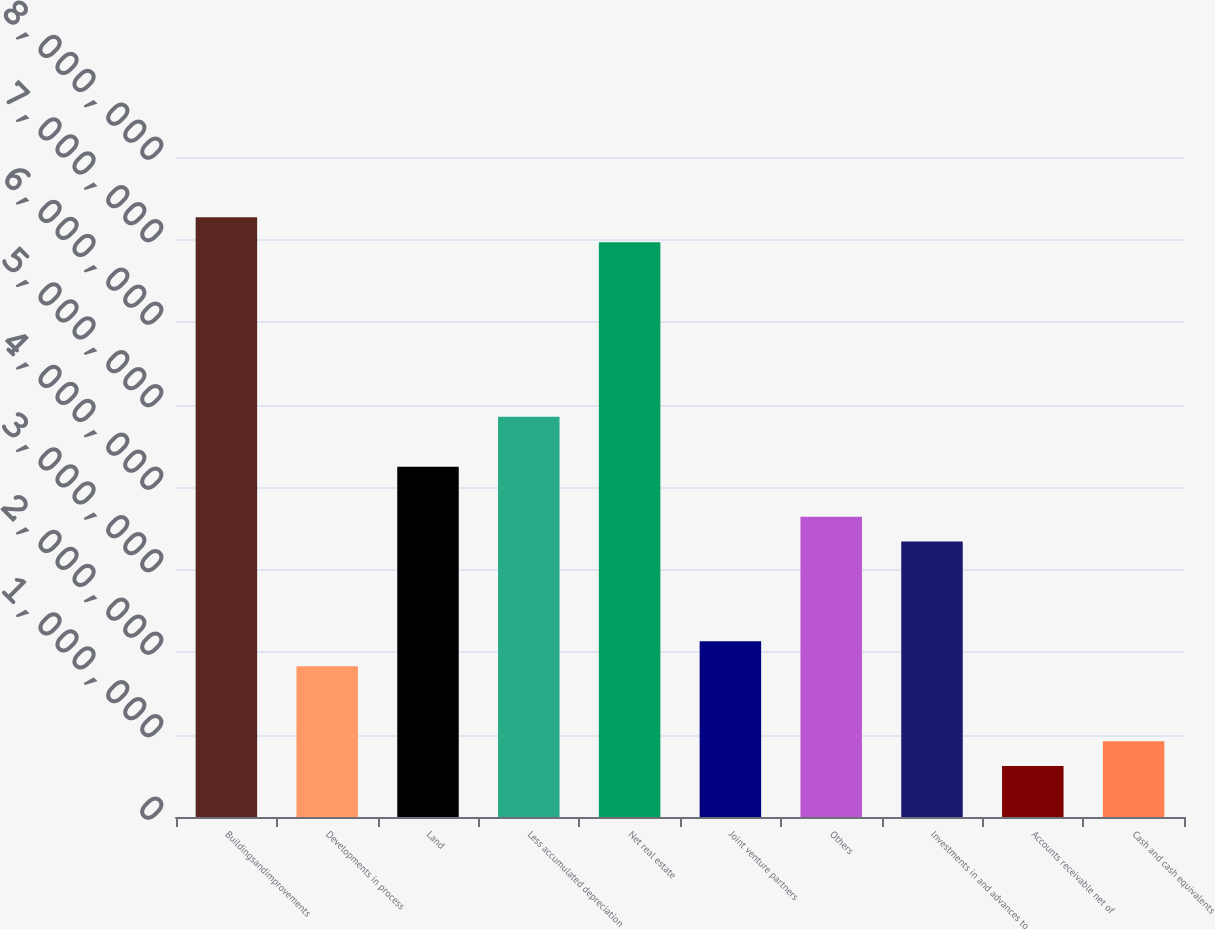Convert chart. <chart><loc_0><loc_0><loc_500><loc_500><bar_chart><fcel>Buildingsandimprovements<fcel>Developments in process<fcel>Land<fcel>Less accumulated depreciation<fcel>Net real estate<fcel>Joint venture partners<fcel>Others<fcel>Investments in and advances to<fcel>Accounts receivable net of<fcel>Cash and cash equivalents<nl><fcel>7.26919e+06<fcel>1.82646e+06<fcel>4.24545e+06<fcel>4.8502e+06<fcel>6.96682e+06<fcel>2.12884e+06<fcel>3.6407e+06<fcel>3.33833e+06<fcel>616965<fcel>919339<nl></chart> 